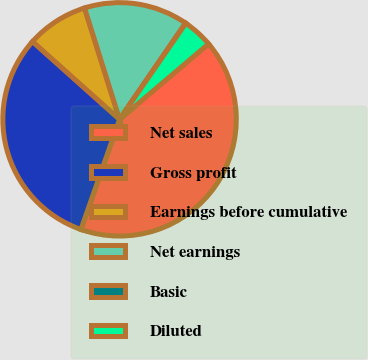Convert chart to OTSL. <chart><loc_0><loc_0><loc_500><loc_500><pie_chart><fcel>Net sales<fcel>Gross profit<fcel>Earnings before cumulative<fcel>Net earnings<fcel>Basic<fcel>Diluted<nl><fcel>41.56%<fcel>31.24%<fcel>8.54%<fcel>14.42%<fcel>0.04%<fcel>4.2%<nl></chart> 